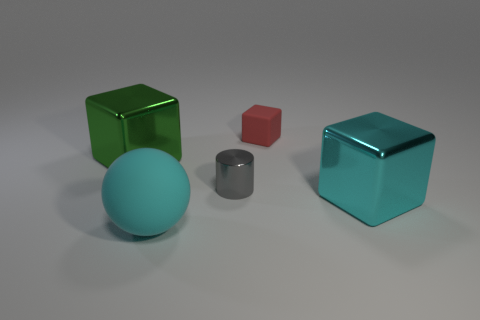What number of other objects are the same color as the small matte object? 0 